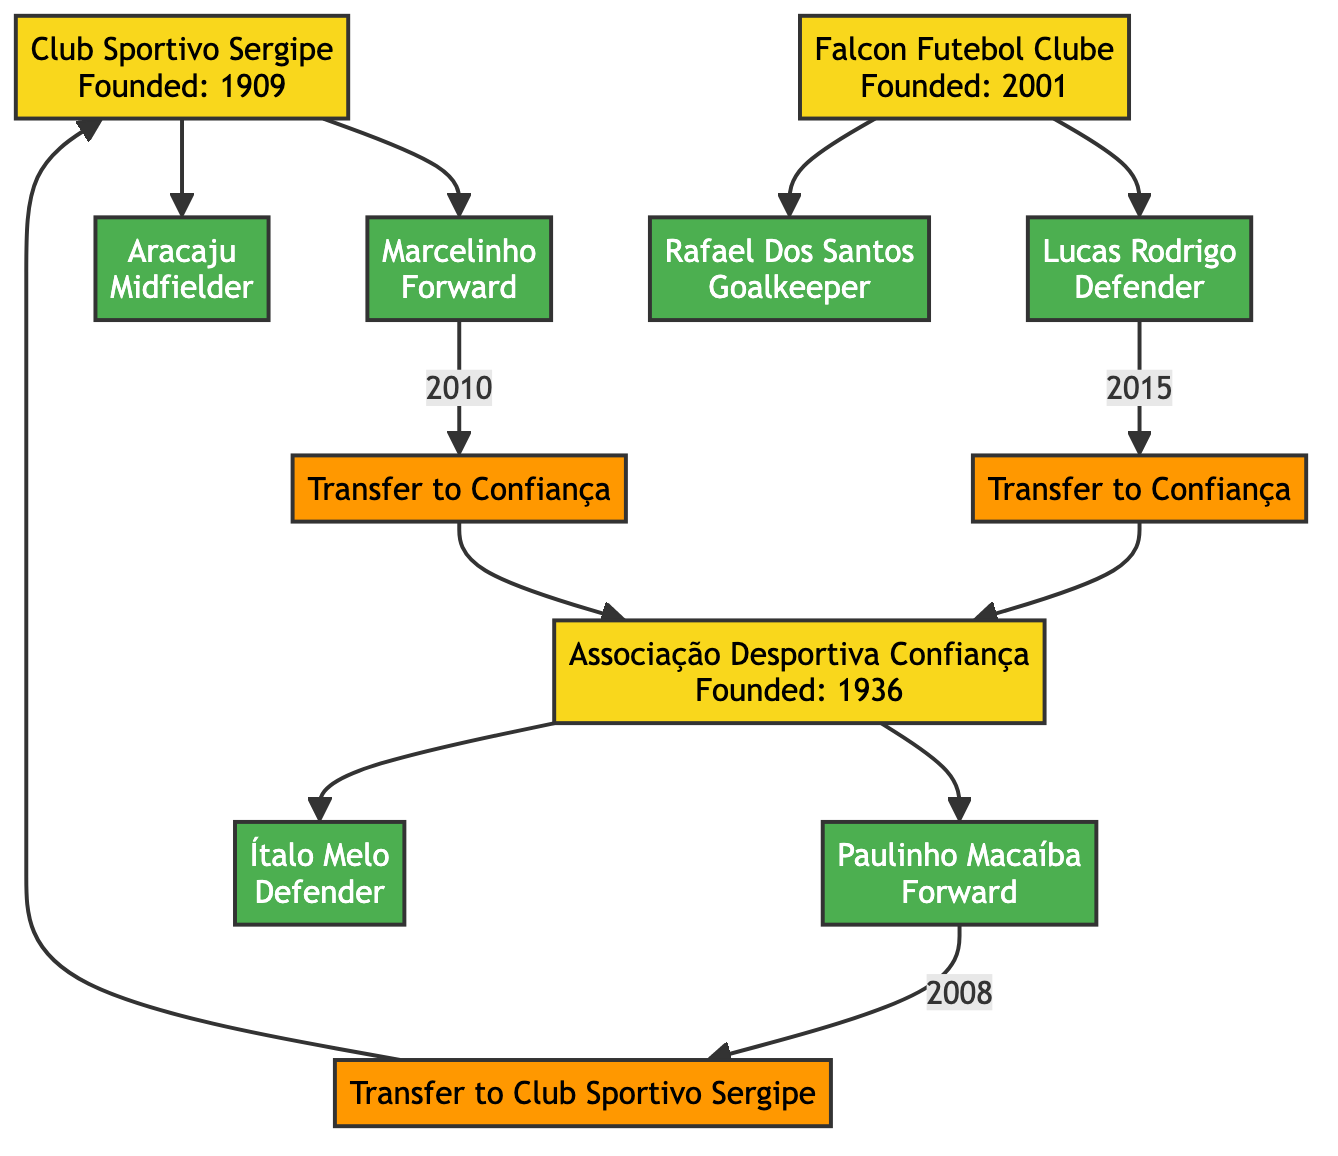What is the founding year of Club Sportivo Sergipe? The diagram indicates that Club Sportivo Sergipe was founded in 1909, as shown directly in the node.
Answer: 1909 How many key players does Falcon Futebol Clube have? By examining the Falcon Futebol Clube node, we can see that it has two key players listed: Lucas Rodrigo and Rafael Dos Santos.
Answer: 2 Which player transferred from Club Sportivo Sergipe to Associação Desportiva Confiança, and in what year? Looking at the transfer information, Marcelinho transferred from Club Sportivo Sergipe to Confiança in 2010, as specified in the transfer node.
Answer: Marcelinho, 2010 What position does Paulinho Macaíba play? The diagram shows Paulinho Macaíba under the key players of Associação Desportiva Confiança with the position labeled as Forward.
Answer: Forward Which club did Lucas Rodrigo transfer to in 2015? The transfer details clarify that Lucas Rodrigo transferred from Falcon Futebol Clube to Confiança in 2015.
Answer: Confiança What stadium do both Club Sportivo Sergipe and Associação Desportiva Confiança share? The diagram lists both clubs sharing the stadium Batistão, directly mentioned in their respective nodes.
Answer: Batistão How many iconic games are listed in the diagram? The Iconic Games section shows three specific matches, meaning there are a total of three iconic games listed.
Answer: 3 Which player scored a hat-trick in the game between Confiança and Falcon? The highlights of the match on June 30, 2020, indicate that Paulinho Macaíba had a hat-trick in that game, clearly stated in the match details.
Answer: Paulinho Macaíba How many years did Aracaju play for Club Sportivo Sergipe? While the diagram lists Aracaju as a key player, it does not specify the career span in the context of Club Sportivo Sergipe. However, his career spanned from 1995 to 2010, which amounts to 15 years.
Answer: 15 years 